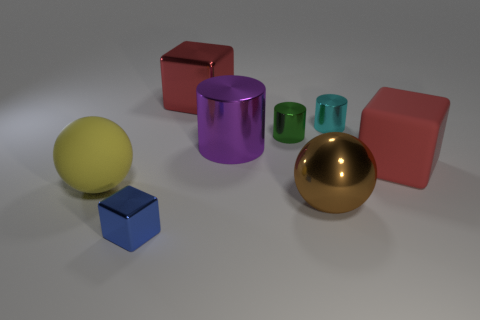Considering the shadows and lighting, what time of day would you say it is? The image seems to be a studio setup with controlled lighting rather than a natural environment. Therefore, we cannot determine the time of day from this image as the shadows and lighting are artificially created. 